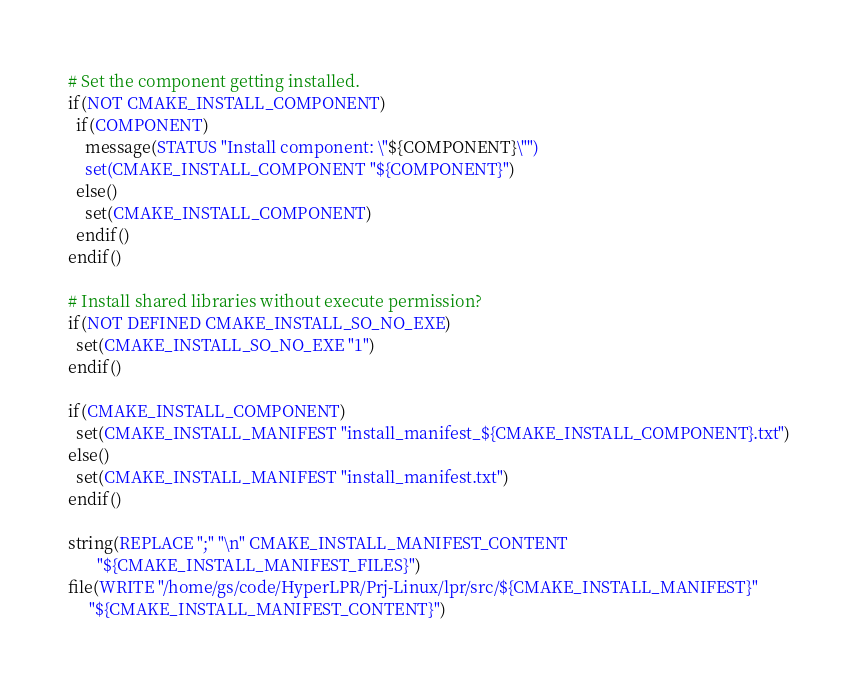Convert code to text. <code><loc_0><loc_0><loc_500><loc_500><_CMake_>
# Set the component getting installed.
if(NOT CMAKE_INSTALL_COMPONENT)
  if(COMPONENT)
    message(STATUS "Install component: \"${COMPONENT}\"")
    set(CMAKE_INSTALL_COMPONENT "${COMPONENT}")
  else()
    set(CMAKE_INSTALL_COMPONENT)
  endif()
endif()

# Install shared libraries without execute permission?
if(NOT DEFINED CMAKE_INSTALL_SO_NO_EXE)
  set(CMAKE_INSTALL_SO_NO_EXE "1")
endif()

if(CMAKE_INSTALL_COMPONENT)
  set(CMAKE_INSTALL_MANIFEST "install_manifest_${CMAKE_INSTALL_COMPONENT}.txt")
else()
  set(CMAKE_INSTALL_MANIFEST "install_manifest.txt")
endif()

string(REPLACE ";" "\n" CMAKE_INSTALL_MANIFEST_CONTENT
       "${CMAKE_INSTALL_MANIFEST_FILES}")
file(WRITE "/home/gs/code/HyperLPR/Prj-Linux/lpr/src/${CMAKE_INSTALL_MANIFEST}"
     "${CMAKE_INSTALL_MANIFEST_CONTENT}")
</code> 